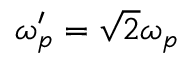Convert formula to latex. <formula><loc_0><loc_0><loc_500><loc_500>\omega _ { p } ^ { \prime } = \sqrt { 2 } \omega _ { p }</formula> 